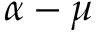<formula> <loc_0><loc_0><loc_500><loc_500>\alpha - \mu</formula> 